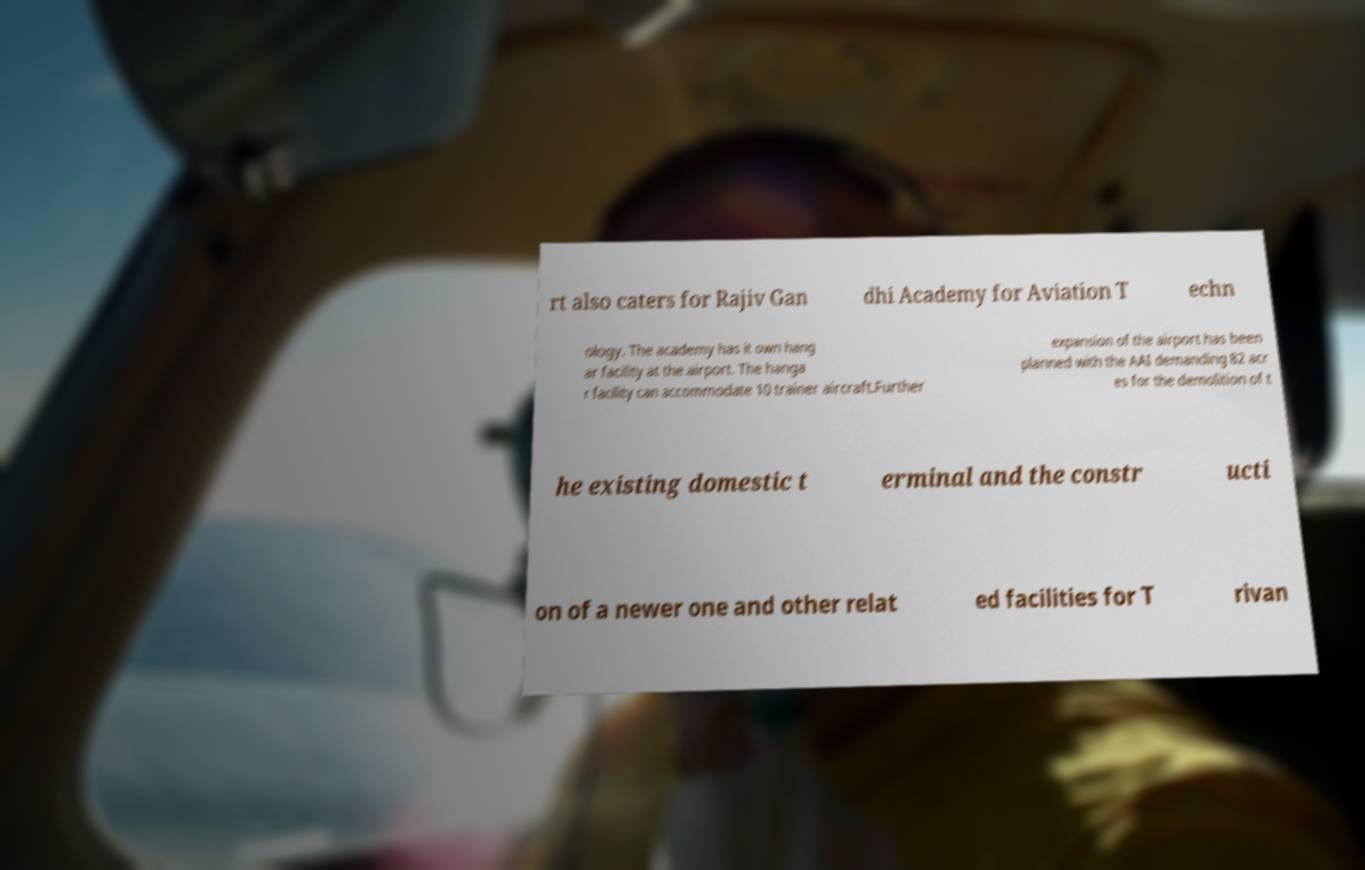Please identify and transcribe the text found in this image. rt also caters for Rajiv Gan dhi Academy for Aviation T echn ology. The academy has it own hang ar facility at the airport. The hanga r facility can accommodate 10 trainer aircraft.Further expansion of the airport has been planned with the AAI demanding 82 acr es for the demolition of t he existing domestic t erminal and the constr ucti on of a newer one and other relat ed facilities for T rivan 